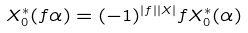<formula> <loc_0><loc_0><loc_500><loc_500>X _ { 0 } ^ { * } ( f \alpha ) = ( - 1 ) ^ { | f | | X | } f X _ { 0 } ^ { * } ( \alpha )</formula> 